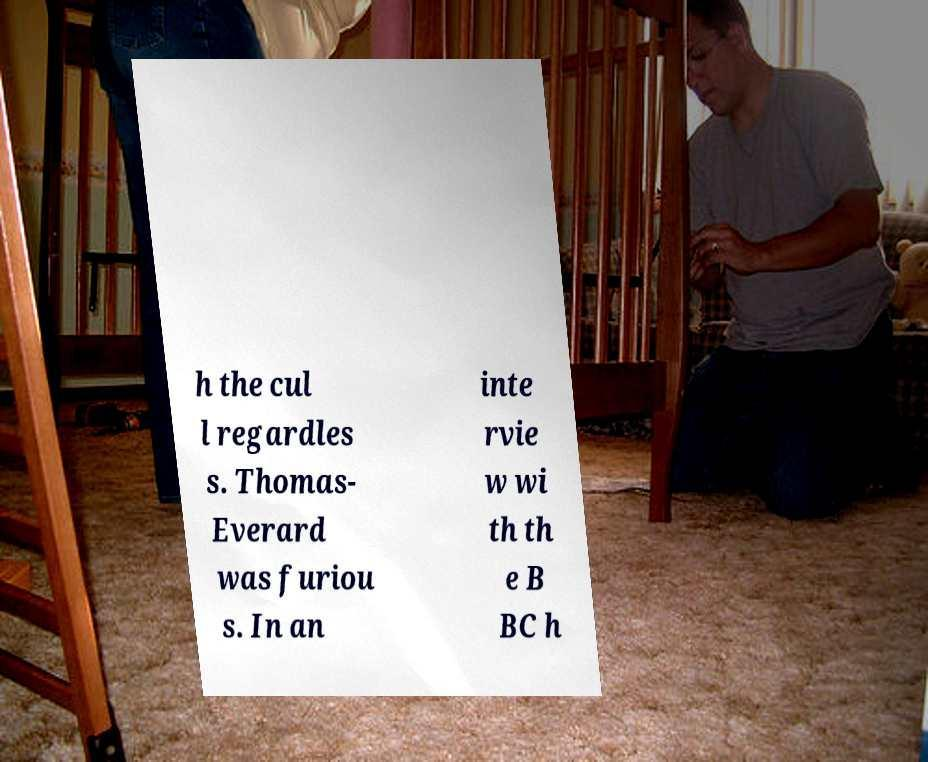Can you accurately transcribe the text from the provided image for me? h the cul l regardles s. Thomas- Everard was furiou s. In an inte rvie w wi th th e B BC h 